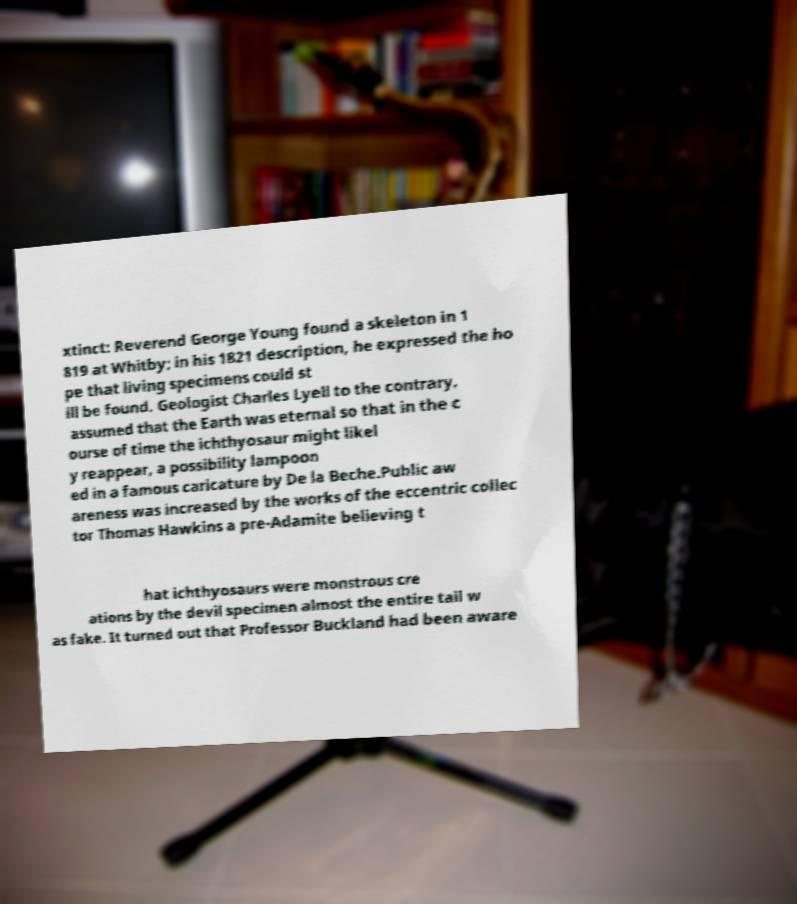Could you assist in decoding the text presented in this image and type it out clearly? xtinct: Reverend George Young found a skeleton in 1 819 at Whitby; in his 1821 description, he expressed the ho pe that living specimens could st ill be found. Geologist Charles Lyell to the contrary, assumed that the Earth was eternal so that in the c ourse of time the ichthyosaur might likel y reappear, a possibility lampoon ed in a famous caricature by De la Beche.Public aw areness was increased by the works of the eccentric collec tor Thomas Hawkins a pre-Adamite believing t hat ichthyosaurs were monstrous cre ations by the devil specimen almost the entire tail w as fake. It turned out that Professor Buckland had been aware 